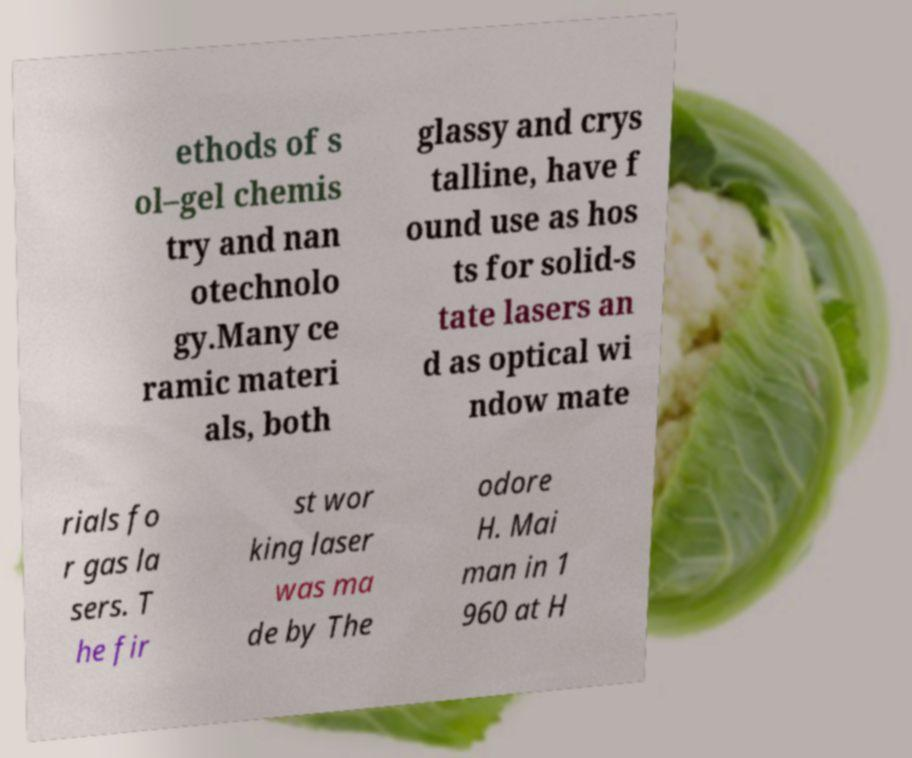Can you read and provide the text displayed in the image?This photo seems to have some interesting text. Can you extract and type it out for me? ethods of s ol–gel chemis try and nan otechnolo gy.Many ce ramic materi als, both glassy and crys talline, have f ound use as hos ts for solid-s tate lasers an d as optical wi ndow mate rials fo r gas la sers. T he fir st wor king laser was ma de by The odore H. Mai man in 1 960 at H 